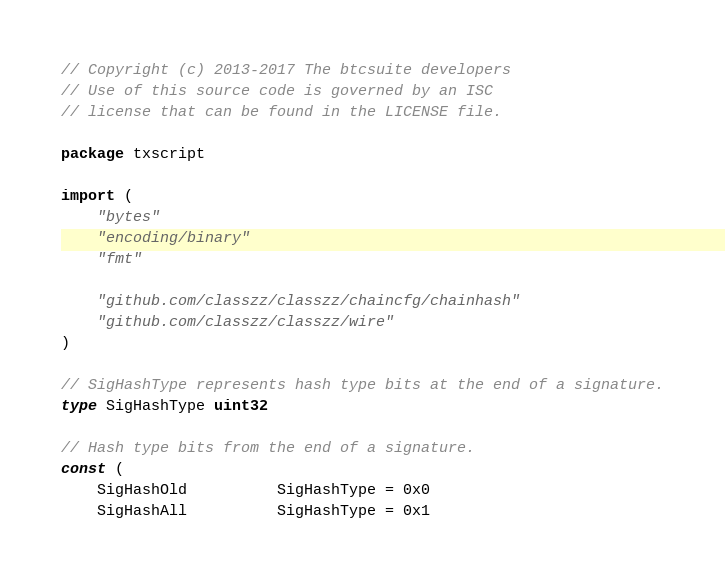Convert code to text. <code><loc_0><loc_0><loc_500><loc_500><_Go_>// Copyright (c) 2013-2017 The btcsuite developers
// Use of this source code is governed by an ISC
// license that can be found in the LICENSE file.

package txscript

import (
	"bytes"
	"encoding/binary"
	"fmt"

	"github.com/classzz/classzz/chaincfg/chainhash"
	"github.com/classzz/classzz/wire"
)

// SigHashType represents hash type bits at the end of a signature.
type SigHashType uint32

// Hash type bits from the end of a signature.
const (
	SigHashOld          SigHashType = 0x0
	SigHashAll          SigHashType = 0x1</code> 